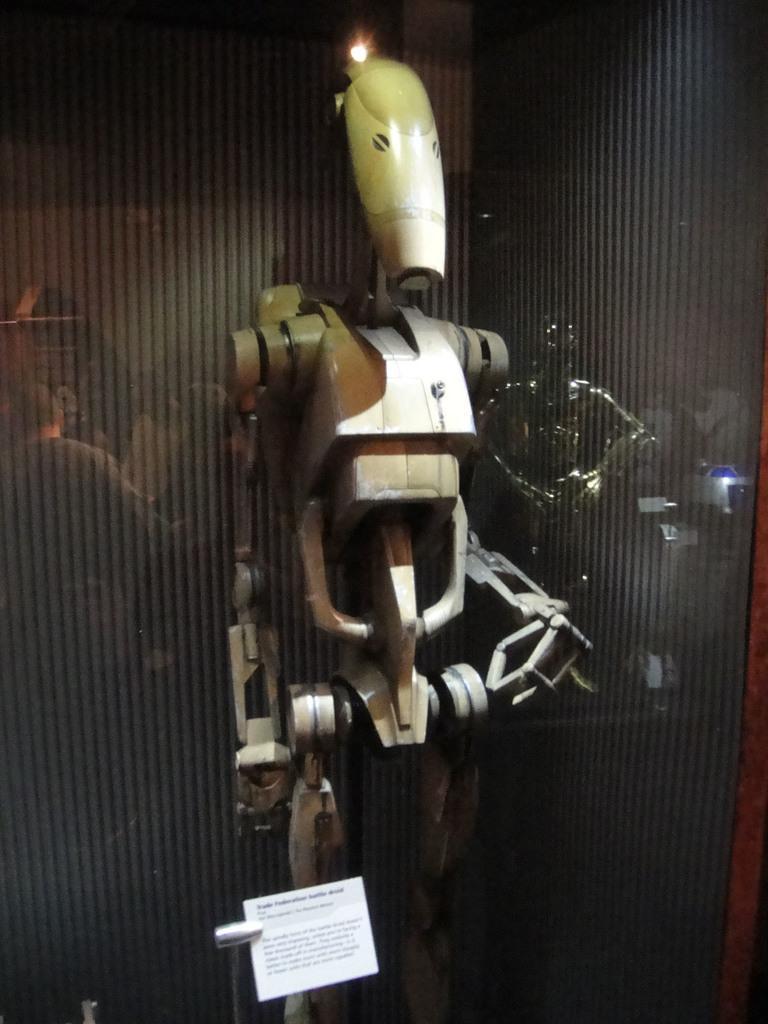Please provide a concise description of this image. In the center of the image we can see a robot. At the bottom there is a board. In the background we can see a reflection of people on the glass. 